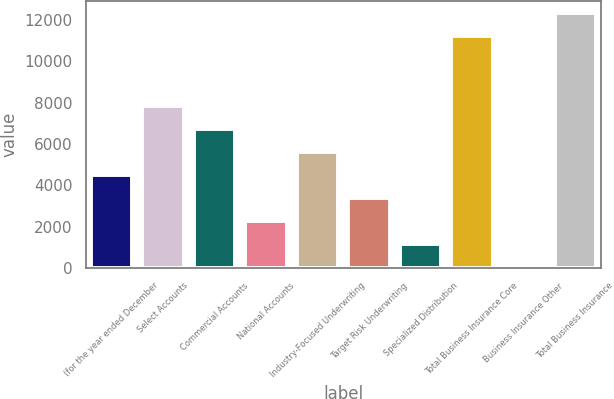<chart> <loc_0><loc_0><loc_500><loc_500><bar_chart><fcel>(for the year ended December<fcel>Select Accounts<fcel>Commercial Accounts<fcel>National Accounts<fcel>Industry-Focused Underwriting<fcel>Target Risk Underwriting<fcel>Specialized Distribution<fcel>Total Business Insurance Core<fcel>Business Insurance Other<fcel>Total Business Insurance<nl><fcel>4497.6<fcel>7858.8<fcel>6738.4<fcel>2256.8<fcel>5618<fcel>3377.2<fcel>1136.4<fcel>11204<fcel>16<fcel>12324.4<nl></chart> 